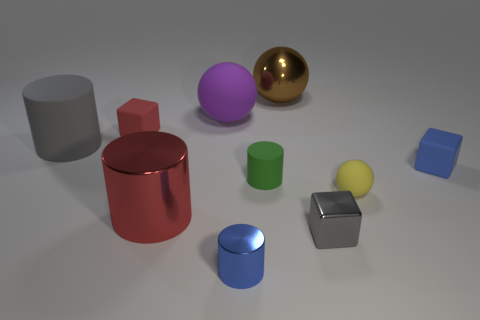The tiny yellow rubber thing has what shape?
Your answer should be compact. Sphere. Is there any other thing that has the same material as the big purple sphere?
Offer a very short reply. Yes. Is the material of the yellow sphere the same as the blue cylinder?
Make the answer very short. No. Are there any red rubber objects that are in front of the thing on the right side of the tiny yellow thing in front of the large purple ball?
Your answer should be very brief. No. How many other things are the same shape as the purple thing?
Keep it short and to the point. 2. The thing that is both left of the purple thing and right of the tiny red object has what shape?
Your response must be concise. Cylinder. What is the color of the tiny metal object behind the tiny blue thing to the left of the blue object on the right side of the brown object?
Keep it short and to the point. Gray. Is the number of purple balls that are behind the blue block greater than the number of gray cylinders right of the large rubber sphere?
Your answer should be very brief. Yes. What number of other objects are there of the same size as the purple matte object?
Your response must be concise. 3. There is a matte thing that is the same color as the shiny cube; what size is it?
Your response must be concise. Large. 